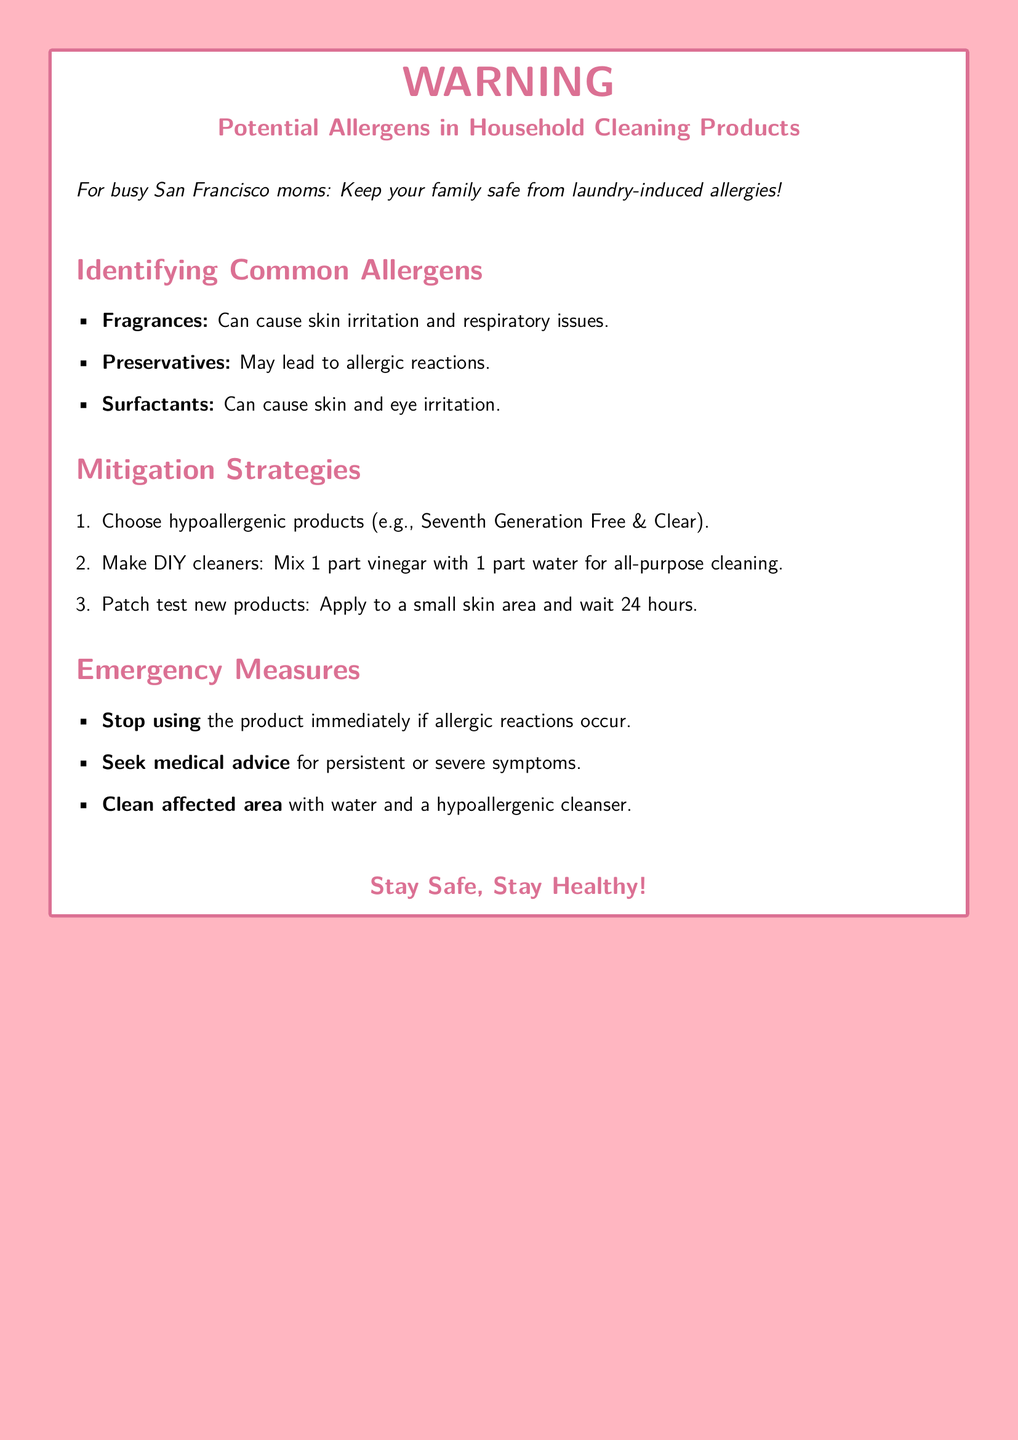What is the main purpose of this warning label? The warning label aims to inform about potential allergens in household cleaning products and provide safety tips for families.
Answer: To inform about potential allergens What is one common allergen listed? The document mentions several common allergens, asking for just one.
Answer: Fragrances What does the document recommend for a hypoallergenic product? The answer is found in the mitigation strategies, where a specific product is suggested.
Answer: Seventh Generation Free & Clear What is the first mitigation strategy mentioned? The first strategy outlines the recommendation for choosing specific types of products to avoid allergens.
Answer: Choose hypoallergenic products What should you do if allergic reactions occur? The emergency measures section specifically addresses how to respond to allergic reactions.
Answer: Stop using the product How long should you wait after a patch test? The document states a specific time frame to observe after applying new products.
Answer: 24 hours What is a DIY cleaner recipe provided? The document provides a mixture ratio for a do-it-yourself cleaning solution.
Answer: 1 part vinegar with 1 part water What type of mothers is this warning label directed towards? The introduction specifies a target demographic for the informational content.
Answer: Busy San Francisco moms 